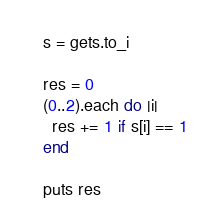<code> <loc_0><loc_0><loc_500><loc_500><_Ruby_>s = gets.to_i

res = 0
(0..2).each do |i|
  res += 1 if s[i] == 1
end

puts res
</code> 